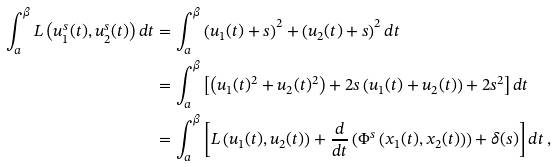<formula> <loc_0><loc_0><loc_500><loc_500>\int _ { a } ^ { \beta } L \left ( u _ { 1 } ^ { s } ( t ) , u _ { 2 } ^ { s } ( t ) \right ) d t & = \int _ { a } ^ { \beta } \left ( u _ { 1 } ( t ) + s \right ) ^ { 2 } + \left ( u _ { 2 } ( t ) + s \right ) ^ { 2 } d t \\ & = \int _ { a } ^ { \beta } \left [ \left ( u _ { 1 } ( t ) ^ { 2 } + u _ { 2 } ( t ) ^ { 2 } \right ) + 2 s \left ( u _ { 1 } ( t ) + u _ { 2 } ( t ) \right ) + 2 s ^ { 2 } \right ] d t \\ & = \int _ { a } ^ { \beta } \left [ L \left ( u _ { 1 } ( t ) , u _ { 2 } ( t ) \right ) + \frac { d } { d t } \left ( \Phi ^ { s } \left ( x _ { 1 } ( t ) , x _ { 2 } ( t ) \right ) \right ) + \delta ( s ) \right ] d t \, ,</formula> 